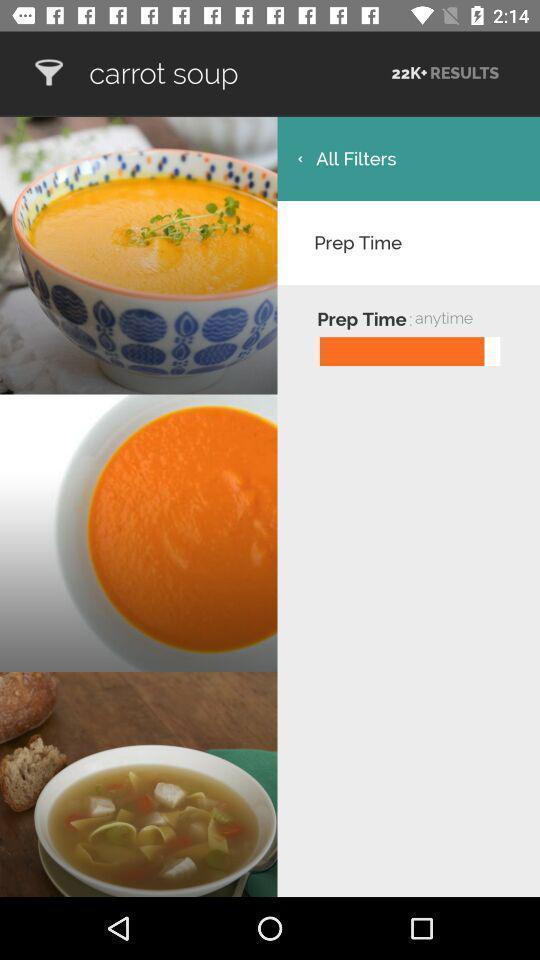What is the overall content of this screenshot? Recipe images are displaying with time details. 